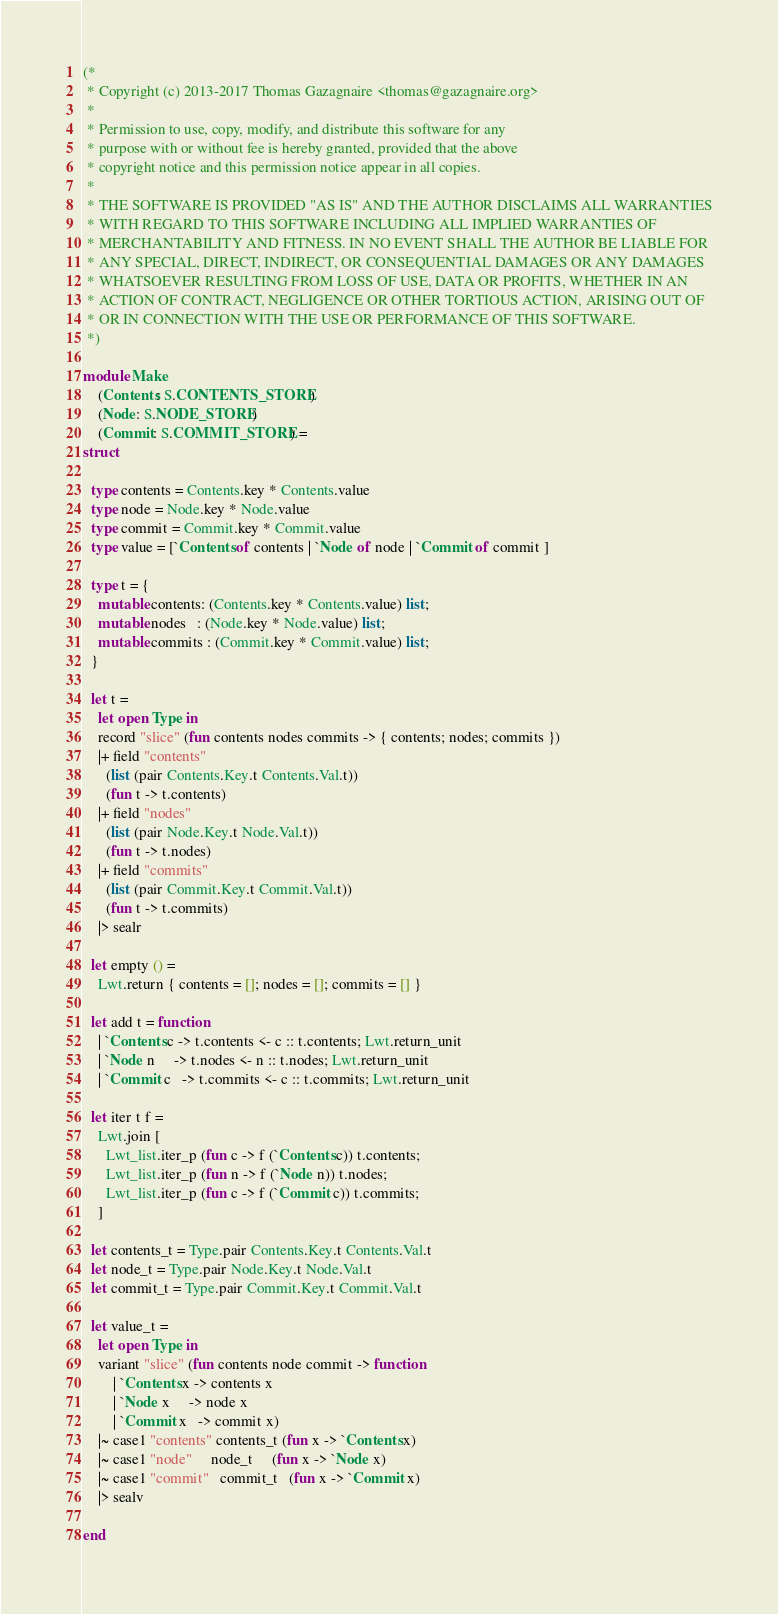<code> <loc_0><loc_0><loc_500><loc_500><_OCaml_>(*
 * Copyright (c) 2013-2017 Thomas Gazagnaire <thomas@gazagnaire.org>
 *
 * Permission to use, copy, modify, and distribute this software for any
 * purpose with or without fee is hereby granted, provided that the above
 * copyright notice and this permission notice appear in all copies.
 *
 * THE SOFTWARE IS PROVIDED "AS IS" AND THE AUTHOR DISCLAIMS ALL WARRANTIES
 * WITH REGARD TO THIS SOFTWARE INCLUDING ALL IMPLIED WARRANTIES OF
 * MERCHANTABILITY AND FITNESS. IN NO EVENT SHALL THE AUTHOR BE LIABLE FOR
 * ANY SPECIAL, DIRECT, INDIRECT, OR CONSEQUENTIAL DAMAGES OR ANY DAMAGES
 * WHATSOEVER RESULTING FROM LOSS OF USE, DATA OR PROFITS, WHETHER IN AN
 * ACTION OF CONTRACT, NEGLIGENCE OR OTHER TORTIOUS ACTION, ARISING OUT OF
 * OR IN CONNECTION WITH THE USE OR PERFORMANCE OF THIS SOFTWARE.
 *)

module Make
    (Contents: S.CONTENTS_STORE)
    (Node: S.NODE_STORE)
    (Commit: S.COMMIT_STORE) =
struct

  type contents = Contents.key * Contents.value
  type node = Node.key * Node.value
  type commit = Commit.key * Commit.value
  type value = [`Contents of contents | `Node of node | `Commit of commit ]

  type t = {
    mutable contents: (Contents.key * Contents.value) list;
    mutable nodes   : (Node.key * Node.value) list;
    mutable commits : (Commit.key * Commit.value) list;
  }

  let t =
    let open Type in
    record "slice" (fun contents nodes commits -> { contents; nodes; commits })
    |+ field "contents"
      (list (pair Contents.Key.t Contents.Val.t))
      (fun t -> t.contents)
    |+ field "nodes"
      (list (pair Node.Key.t Node.Val.t))
      (fun t -> t.nodes)
    |+ field "commits"
      (list (pair Commit.Key.t Commit.Val.t))
      (fun t -> t.commits)
    |> sealr

  let empty () =
    Lwt.return { contents = []; nodes = []; commits = [] }

  let add t = function
    | `Contents c -> t.contents <- c :: t.contents; Lwt.return_unit
    | `Node n     -> t.nodes <- n :: t.nodes; Lwt.return_unit
    | `Commit c   -> t.commits <- c :: t.commits; Lwt.return_unit

  let iter t f =
    Lwt.join [
      Lwt_list.iter_p (fun c -> f (`Contents c)) t.contents;
      Lwt_list.iter_p (fun n -> f (`Node n)) t.nodes;
      Lwt_list.iter_p (fun c -> f (`Commit c)) t.commits;
    ]

  let contents_t = Type.pair Contents.Key.t Contents.Val.t
  let node_t = Type.pair Node.Key.t Node.Val.t
  let commit_t = Type.pair Commit.Key.t Commit.Val.t

  let value_t =
    let open Type in
    variant "slice" (fun contents node commit -> function
        | `Contents x -> contents x
        | `Node x     -> node x
        | `Commit x   -> commit x)
    |~ case1 "contents" contents_t (fun x -> `Contents x)
    |~ case1 "node"     node_t     (fun x -> `Node x)
    |~ case1 "commit"   commit_t   (fun x -> `Commit x)
    |> sealv

end
</code> 